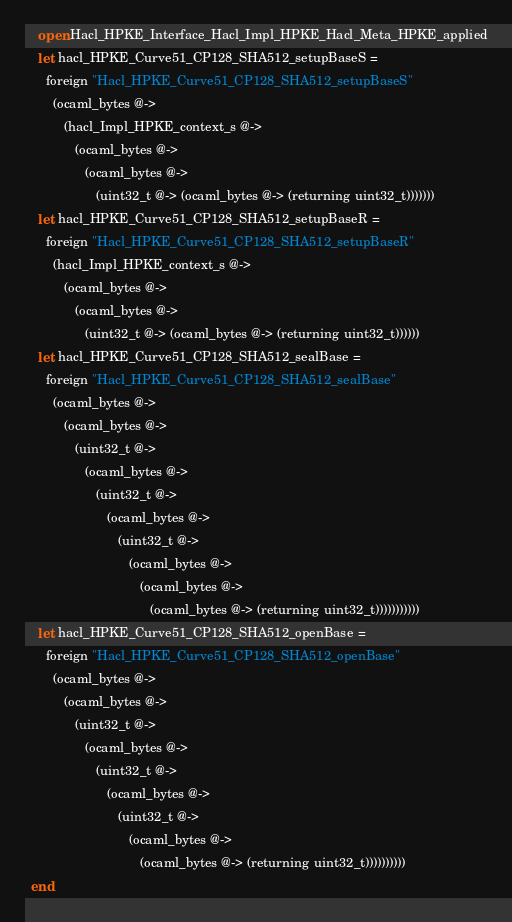Convert code to text. <code><loc_0><loc_0><loc_500><loc_500><_OCaml_>    open Hacl_HPKE_Interface_Hacl_Impl_HPKE_Hacl_Meta_HPKE_applied
    let hacl_HPKE_Curve51_CP128_SHA512_setupBaseS =
      foreign "Hacl_HPKE_Curve51_CP128_SHA512_setupBaseS"
        (ocaml_bytes @->
           (hacl_Impl_HPKE_context_s @->
              (ocaml_bytes @->
                 (ocaml_bytes @->
                    (uint32_t @-> (ocaml_bytes @-> (returning uint32_t)))))))
    let hacl_HPKE_Curve51_CP128_SHA512_setupBaseR =
      foreign "Hacl_HPKE_Curve51_CP128_SHA512_setupBaseR"
        (hacl_Impl_HPKE_context_s @->
           (ocaml_bytes @->
              (ocaml_bytes @->
                 (uint32_t @-> (ocaml_bytes @-> (returning uint32_t))))))
    let hacl_HPKE_Curve51_CP128_SHA512_sealBase =
      foreign "Hacl_HPKE_Curve51_CP128_SHA512_sealBase"
        (ocaml_bytes @->
           (ocaml_bytes @->
              (uint32_t @->
                 (ocaml_bytes @->
                    (uint32_t @->
                       (ocaml_bytes @->
                          (uint32_t @->
                             (ocaml_bytes @->
                                (ocaml_bytes @->
                                   (ocaml_bytes @-> (returning uint32_t)))))))))))
    let hacl_HPKE_Curve51_CP128_SHA512_openBase =
      foreign "Hacl_HPKE_Curve51_CP128_SHA512_openBase"
        (ocaml_bytes @->
           (ocaml_bytes @->
              (uint32_t @->
                 (ocaml_bytes @->
                    (uint32_t @->
                       (ocaml_bytes @->
                          (uint32_t @->
                             (ocaml_bytes @->
                                (ocaml_bytes @-> (returning uint32_t))))))))))
  end</code> 